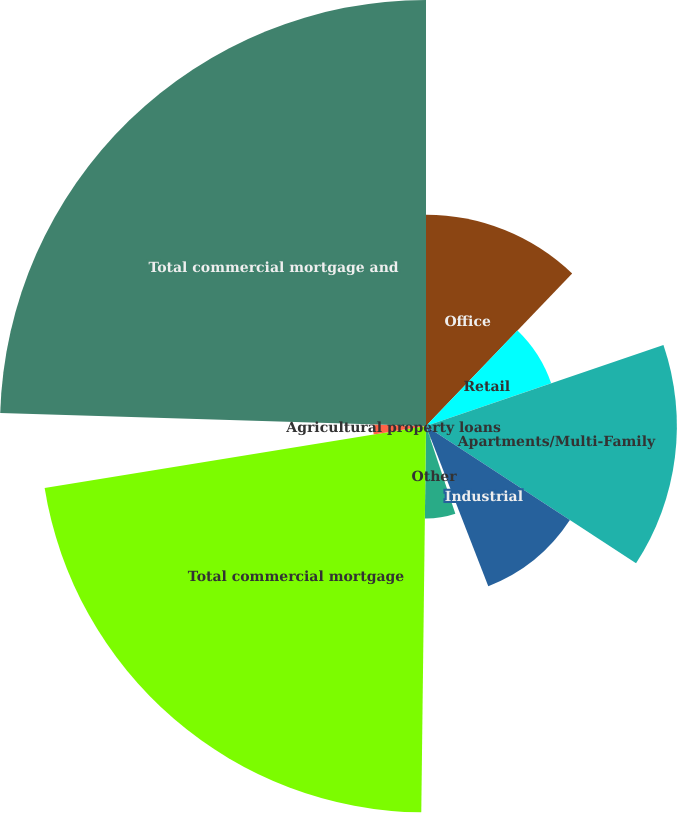Convert chart. <chart><loc_0><loc_0><loc_500><loc_500><pie_chart><fcel>Office<fcel>Retail<fcel>Apartments/Multi-Family<fcel>Industrial<fcel>Hospitality<fcel>Other<fcel>Total commercial mortgage<fcel>Agricultural property loans<fcel>Total commercial mortgage and<nl><fcel>12.16%<fcel>7.61%<fcel>14.44%<fcel>9.89%<fcel>0.77%<fcel>5.33%<fcel>22.24%<fcel>3.05%<fcel>24.52%<nl></chart> 